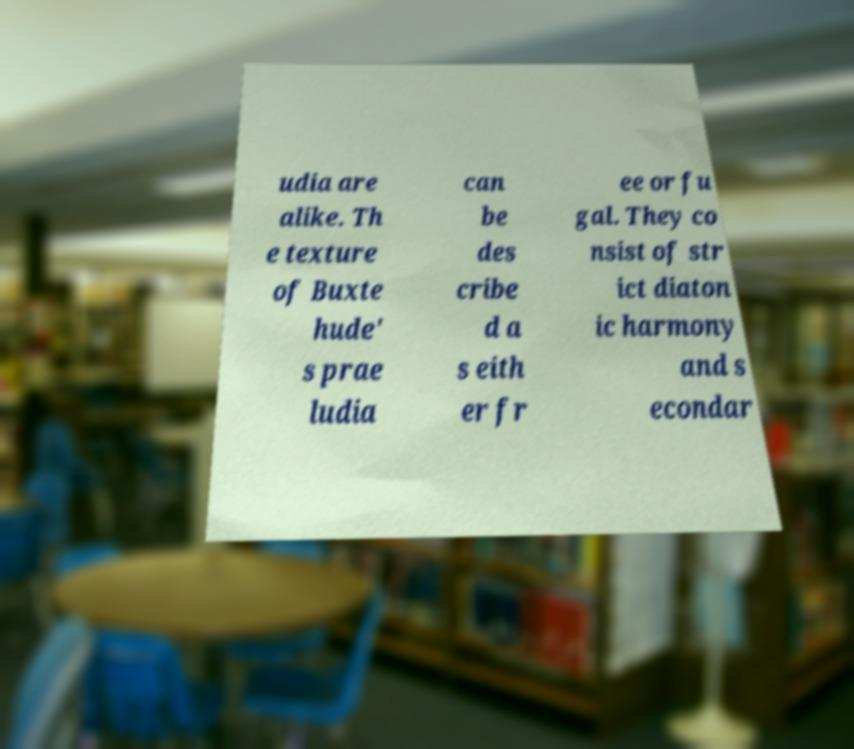Could you assist in decoding the text presented in this image and type it out clearly? udia are alike. Th e texture of Buxte hude' s prae ludia can be des cribe d a s eith er fr ee or fu gal. They co nsist of str ict diaton ic harmony and s econdar 